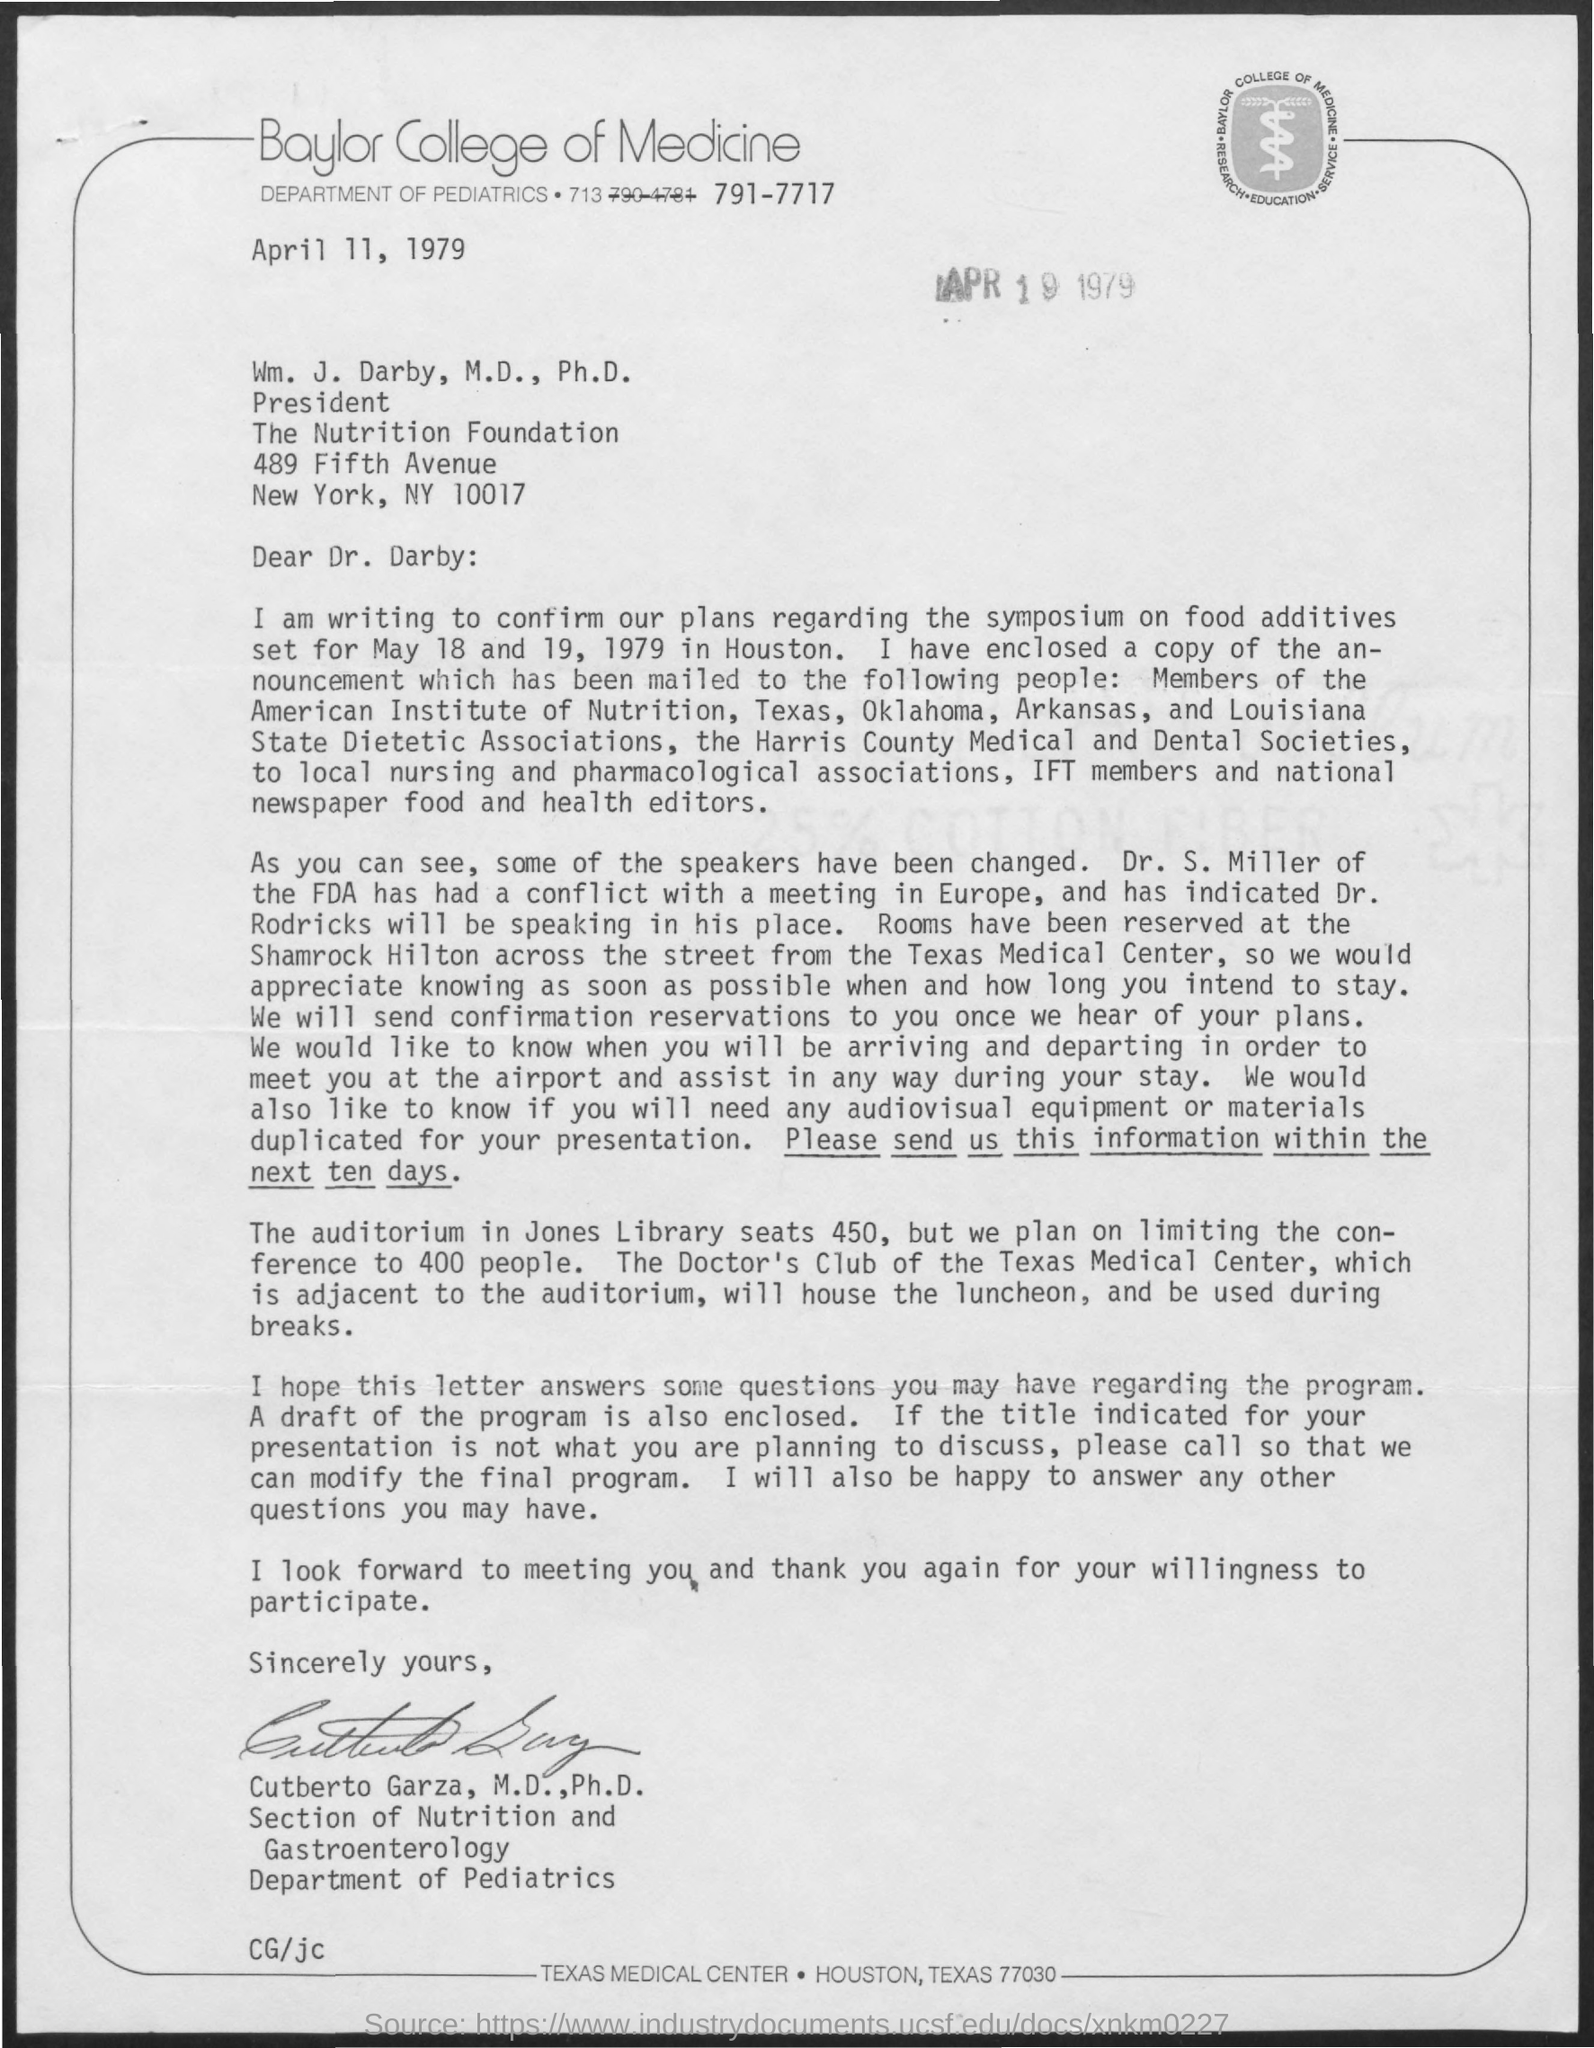Specify some key components in this picture. It is Dr. Rodricks who is speaking in place of Dr. S Miller. 